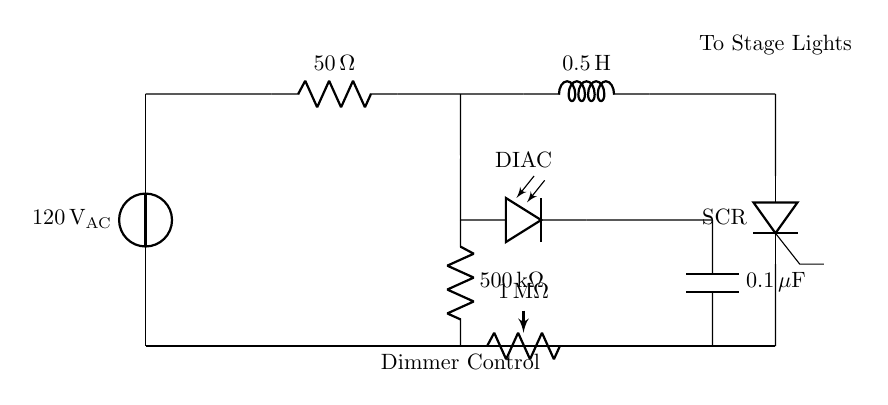What is the voltage source in the circuit? The circuit uses a voltage source labeled as 120 volts AC, which indicates the supplied voltage for the entire dimmer circuit.
Answer: 120 volts AC What is the resistance value of the resistor in the circuit? The circuit contains a resistor with a value of 50 ohms, which is indicated next to the resistor symbol in the diagram.
Answer: 50 ohms What component acts as the dimmer control? The dimmer control in the circuit is represented by a potentiometer with a value of 1 megaohm, which allows adjustment of the light intensity.
Answer: 1 megaohm How many components are in series in this circuit? The circuit includes multiple components positioned in series: the voltage source, resistor, inductor, and thyristor. Counting these together gives four components in series.
Answer: 4 Which component is responsible for triggering the SCR? The component responsible for triggering the SCR is the DIAC placed in the circuit, as it helps control the firing angle of the SCR during the AC cycle.
Answer: DIAC What is the capacitance value in the circuit? The circuit features a capacitor labeled as 0.1 microfarads, as shown next to the capacitor symbol.
Answer: 0.1 microfarads What type of circuit is represented here? This circuit is categorized as a dimmer circuit used for controlling stage lighting, incorporating components designed to adjust the brightness of the lights.
Answer: Dimmer circuit 